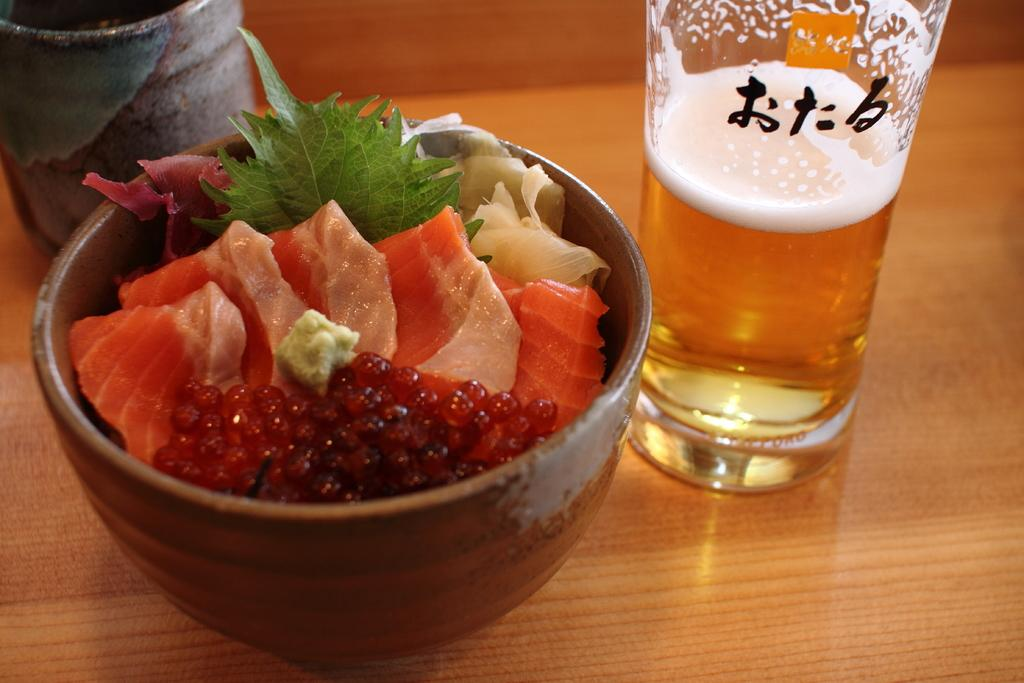What is on the wooden surface in the image? There is a glass with liquid and a bowl with food on the wooden surface. What type of container is holding the liquid? The liquid is in a glass. What type of dish is holding the food? The food is in a bowl. What type of bird is sitting on the queen's shoulder in the image? There is no queen or bird present in the image; it only features a glass with liquid and a bowl with food on a wooden surface. 